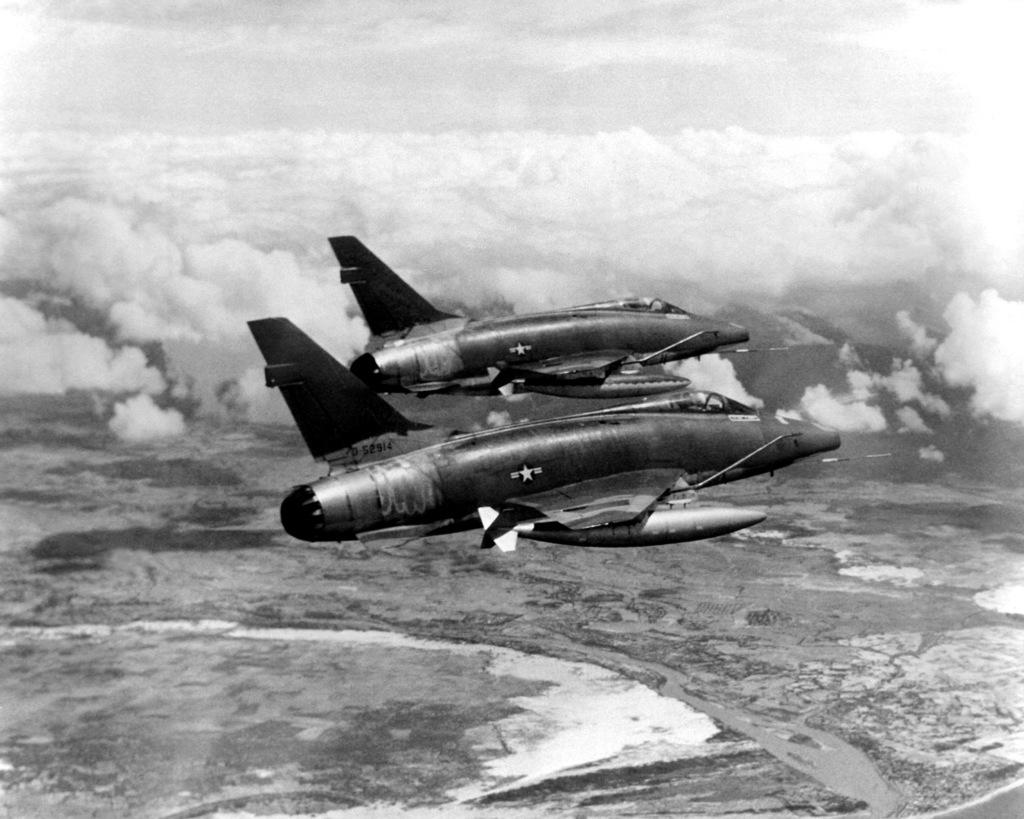How many airplanes are in the image? There are two airplanes in the image. What are the airplanes doing in the image? The airplanes are flying in the air. What can be seen in the sky in the image? There are clouds visible in the image. What is the color scheme of the image? The image is black and white in color. What type of verse can be heard being recited by the airplanes in the image? There is no indication in the image that the airplanes are reciting any verses, as airplanes do not have the ability to speak or recite. 